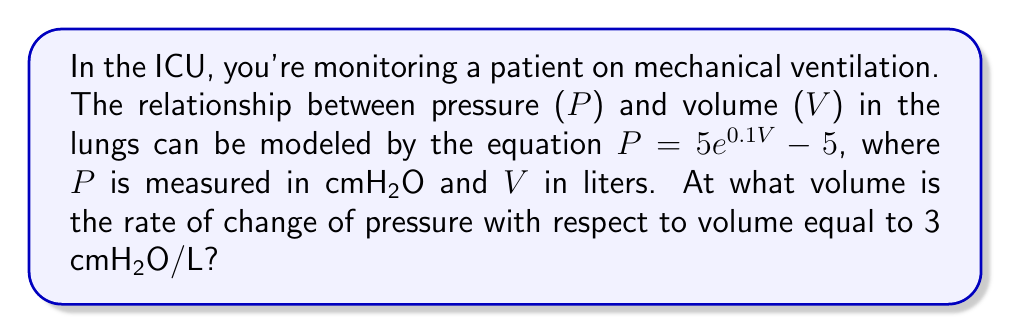Can you solve this math problem? To solve this problem, we need to follow these steps:

1) First, we need to find the derivative of the pressure function with respect to volume:

   $P = 5e^{0.1V} - 5$
   
   $\frac{dP}{dV} = 5 \cdot 0.1 \cdot e^{0.1V} = 0.5e^{0.1V}$

2) We're told that the rate of change of pressure with respect to volume is equal to 3 cmH2O/L. So we can set up the equation:

   $0.5e^{0.1V} = 3$

3) To solve for V, we need to apply natural logarithm to both sides:

   $\ln(0.5e^{0.1V}) = \ln(3)$

4) Using the properties of logarithms:

   $\ln(0.5) + 0.1V = \ln(3)$

5) Subtract ln(0.5) from both sides:

   $0.1V = \ln(3) - \ln(0.5) = \ln(6)$

6) Finally, divide both sides by 0.1:

   $V = \frac{\ln(6)}{0.1} \approx 17.97$ L

Therefore, the rate of change of pressure with respect to volume is equal to 3 cmH2O/L when the volume is approximately 17.97 liters.
Answer: $17.97$ L 